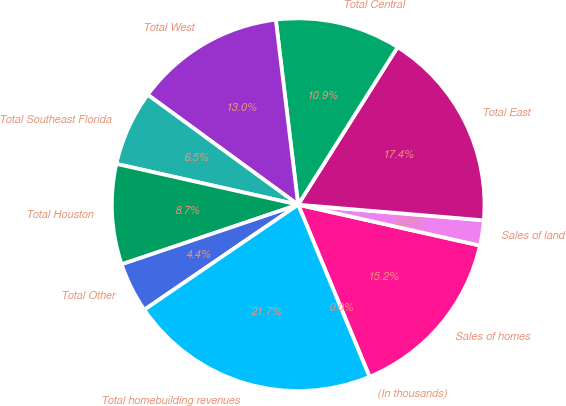Convert chart. <chart><loc_0><loc_0><loc_500><loc_500><pie_chart><fcel>(In thousands)<fcel>Sales of homes<fcel>Sales of land<fcel>Total East<fcel>Total Central<fcel>Total West<fcel>Total Southeast Florida<fcel>Total Houston<fcel>Total Other<fcel>Total homebuilding revenues<nl><fcel>0.01%<fcel>15.21%<fcel>2.18%<fcel>17.38%<fcel>10.87%<fcel>13.04%<fcel>6.53%<fcel>8.7%<fcel>4.35%<fcel>21.72%<nl></chart> 